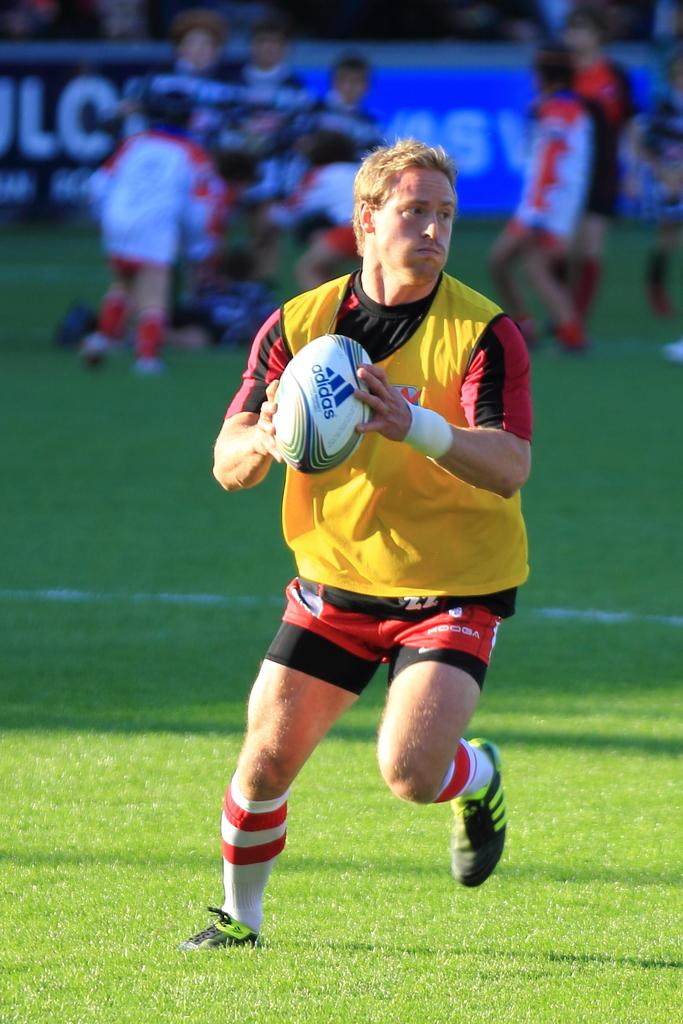Who is the main subject in the image? There is a man in the image. What is the man holding in the image? The man is holding a ball. What type of surface is the man standing on? The man is standing on grass. Can you describe the people behind the man? There are groups of people behind the man. What else can be seen in the image besides the man and the groups of people? There are boards visible in the image. What type of payment is being made by the man in the image? There is no indication of any payment being made in the image; the man is holding a ball. What song is being sung by the groups of people behind the man? There is no indication of any singing or song in the image; the groups of people are simply standing behind the man. 